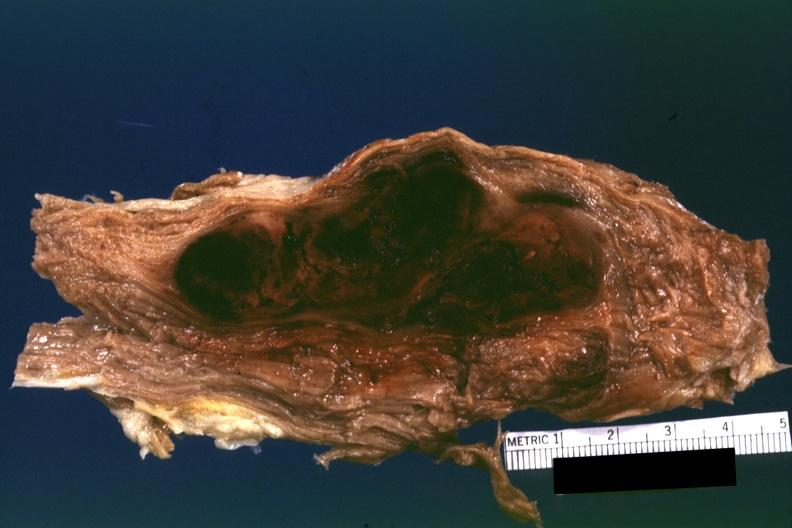what is this this appears to be in a psoas muscle if so the diagnosis on all other slides of this case in this file needs to be changed?
Answer the question using a single word or phrase. What 